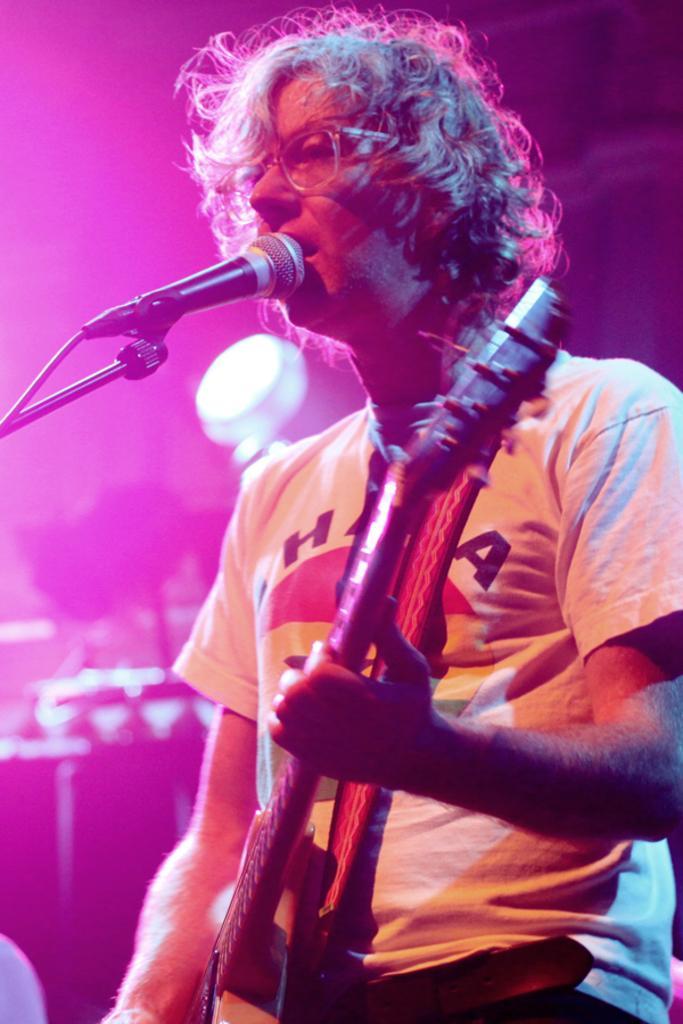Can you describe this image briefly? In this image there is a person playing a guitar and singing a song in a microphone. 